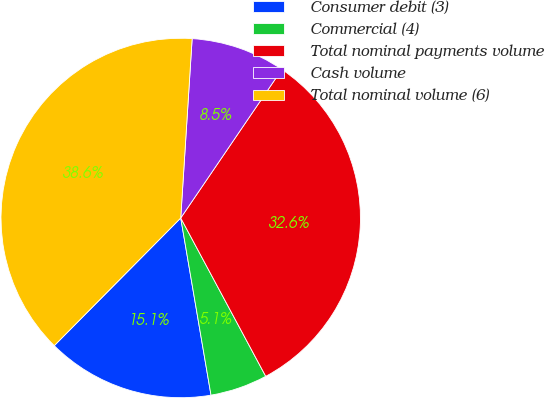<chart> <loc_0><loc_0><loc_500><loc_500><pie_chart><fcel>Consumer debit (3)<fcel>Commercial (4)<fcel>Total nominal payments volume<fcel>Cash volume<fcel>Total nominal volume (6)<nl><fcel>15.12%<fcel>5.15%<fcel>32.65%<fcel>8.5%<fcel>38.59%<nl></chart> 